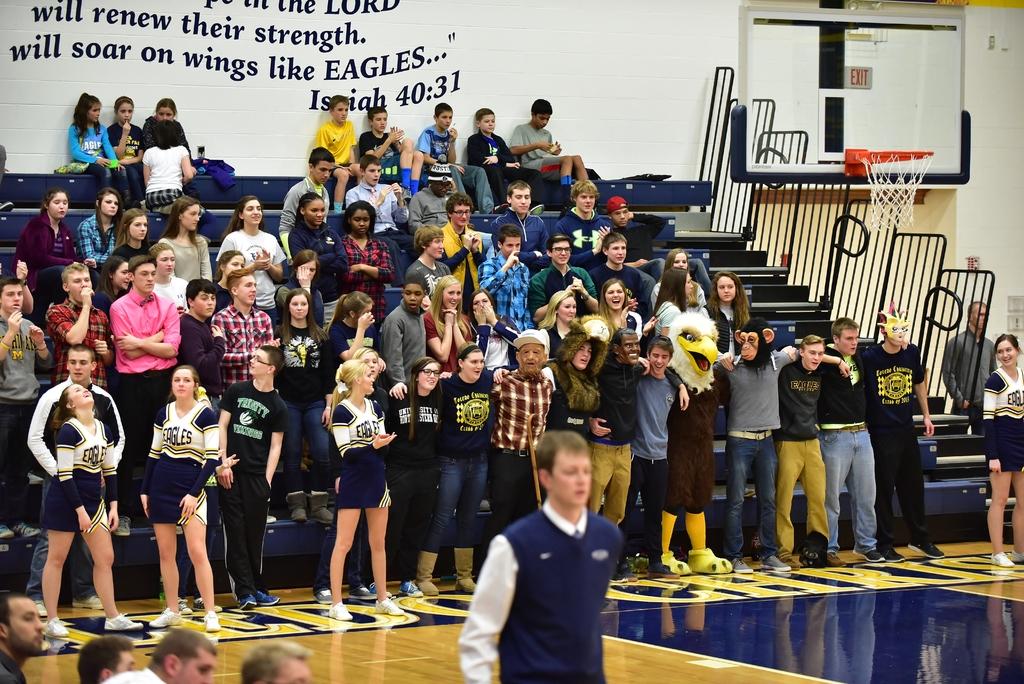What book of the bible is the quote on the wall from?
Ensure brevity in your answer.  Isaiah. What kind of wings are they talking about?
Make the answer very short. Eagles. 